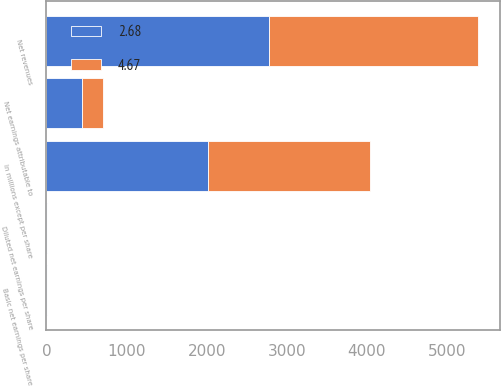Convert chart. <chart><loc_0><loc_0><loc_500><loc_500><stacked_bar_chart><ecel><fcel>In millions except per share<fcel>Net revenues<fcel>Net earnings attributable to<fcel>Basic net earnings per share<fcel>Diluted net earnings per share<nl><fcel>2.68<fcel>2018<fcel>2774.2<fcel>446.8<fcel>4.7<fcel>4.67<nl><fcel>4.67<fcel>2017<fcel>2612.1<fcel>256.9<fcel>2.7<fcel>2.68<nl></chart> 